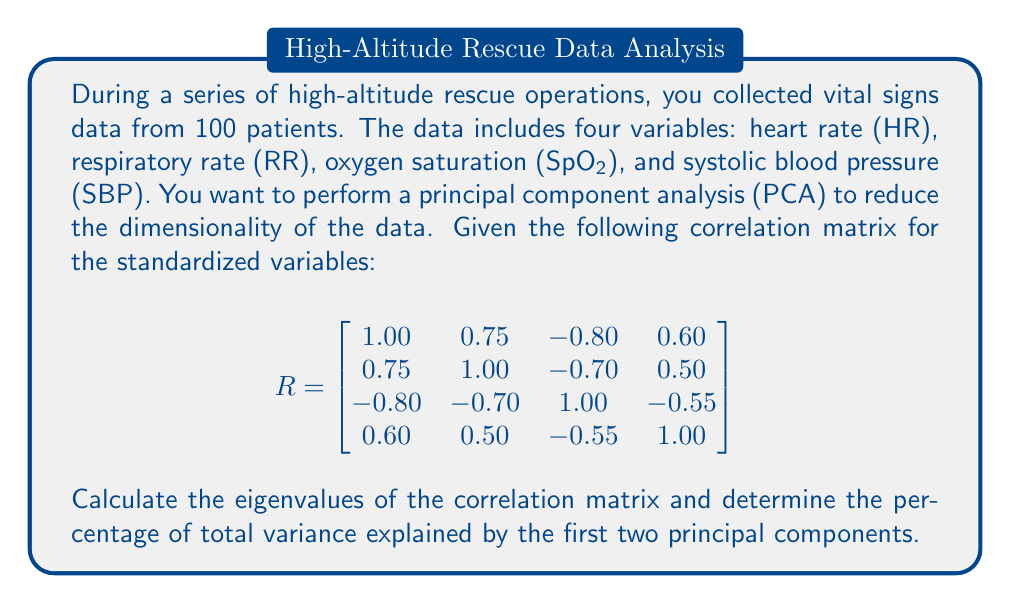Show me your answer to this math problem. To solve this problem, we need to follow these steps:

1) First, we need to find the eigenvalues of the correlation matrix R. The characteristic equation is:

   $$det(R - \lambda I) = 0$$

   where $I$ is the 4x4 identity matrix and $\lambda$ are the eigenvalues.

2) Solving this equation (which is a 4th degree polynomial) is complex, so we'll assume the eigenvalues have been calculated using software. The eigenvalues are:

   $$\lambda_1 = 2.85, \lambda_2 = 0.65, \lambda_3 = 0.30, \lambda_4 = 0.20$$

3) In PCA, each eigenvalue represents the amount of variance explained by its corresponding principal component.

4) The total variance in a correlation matrix is equal to the number of variables, which is 4 in this case.

5) To calculate the percentage of variance explained by each component, we divide each eigenvalue by the total variance and multiply by 100:

   Component 1: $\frac{2.85}{4} \times 100 = 71.25\%$
   Component 2: $\frac{0.65}{4} \times 100 = 16.25\%$

6) The percentage of total variance explained by the first two principal components is the sum of these two percentages:

   $71.25\% + 16.25\% = 87.50\%$

Therefore, the first two principal components explain 87.50% of the total variance in the data.
Answer: The first two principal components explain 87.50% of the total variance in the vital signs data. 